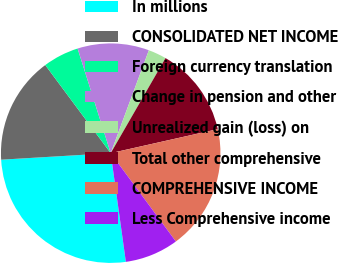Convert chart to OTSL. <chart><loc_0><loc_0><loc_500><loc_500><pie_chart><fcel>In millions<fcel>CONSOLIDATED NET INCOME<fcel>Foreign currency translation<fcel>Change in pension and other<fcel>Unrealized gain (loss) on<fcel>Total other comprehensive<fcel>COMPREHENSIVE INCOME<fcel>Less Comprehensive income<nl><fcel>26.26%<fcel>15.78%<fcel>5.29%<fcel>10.53%<fcel>2.67%<fcel>13.16%<fcel>18.4%<fcel>7.91%<nl></chart> 